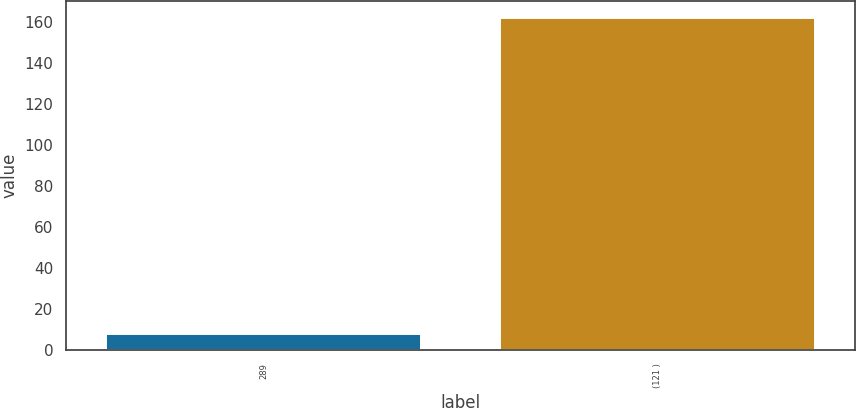<chart> <loc_0><loc_0><loc_500><loc_500><bar_chart><fcel>289<fcel>(121 )<nl><fcel>8<fcel>162<nl></chart> 